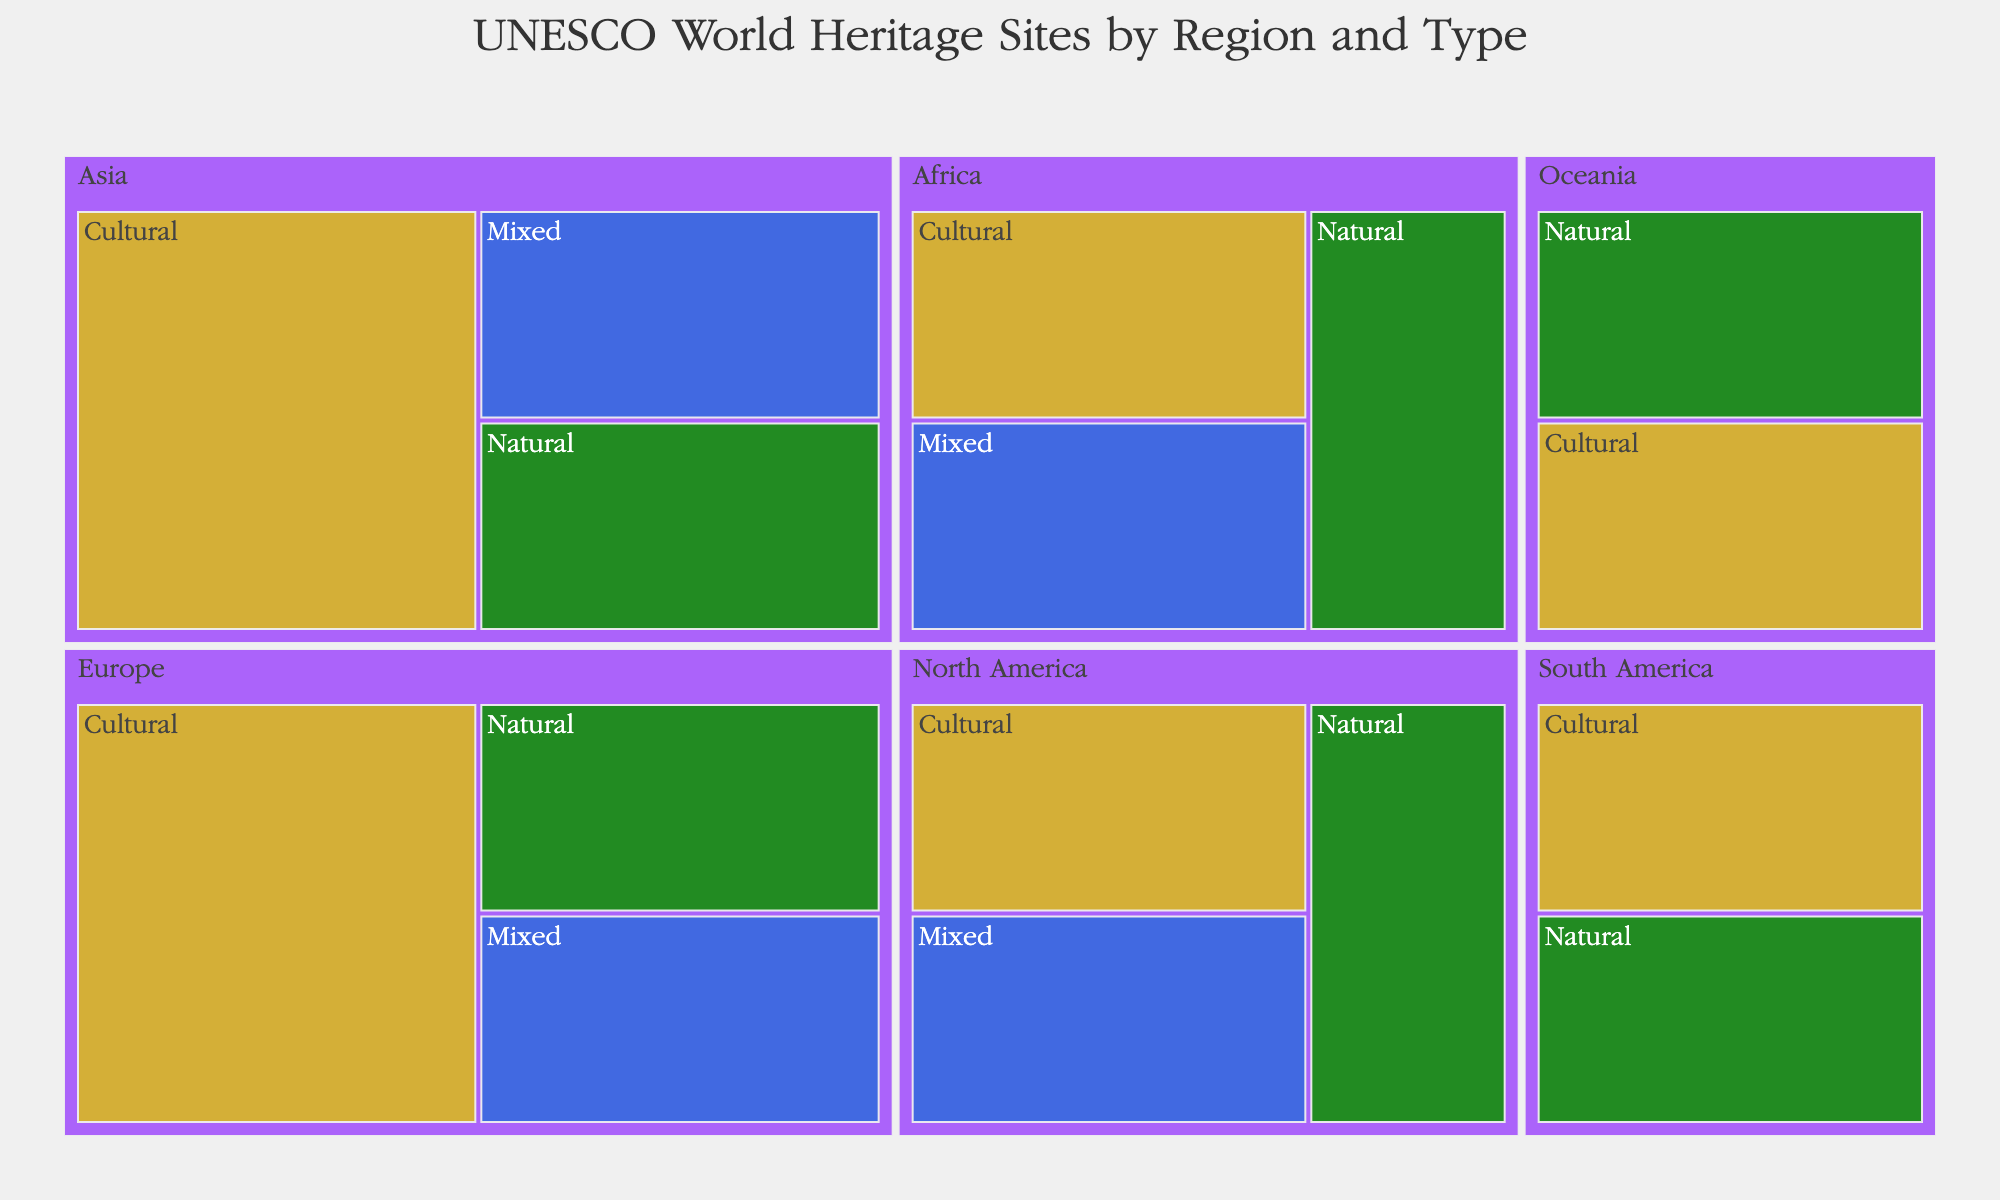What is the title of the treemap? The title is typically displayed at the top of the treemap. It provides a brief description of what the treemap represents.
Answer: UNESCO World Heritage Sites by Region and Type What color represents Natural sites? In the treemap, each type of site is represented by a distinct color. By looking at the color legend or directly at the sections filled with certain colors, we can identify which color corresponds to Natural sites.
Answer: Forest Green How many UNESCO World Heritage Sites are listed in Europe? To find out the total number of sites in Europe, we need to sum the counts for all types in that region. According to the data, Europe has Cultural (1), Natural (1), and Mixed (1) sites. The total number is 1 + 1 + 1.
Answer: 3 Which region has the highest number of Mixed sites? In the treemap, each region has sections representing different types of sites. By identifying the size or count of Mixed sites across different regions, we can determine which region has the highest number.
Answer: It is a tie between Europe, Asia, Africa, and North America How does the count of Cultural sites in Asia compare to the count in South America? By examining the Cultural sections for both Asia and South America and noting the counts in each, we can compare the two. According to the data, Asia has 2 Cultural sites (Great Wall of China and Taj Mahal), and South America has 1 (Historic Centre of Lima). Thus, 2 is greater than 1.
Answer: Asia has more Cultural sites What is the proportion of Natural sites in Africa compared to total sites in Africa? To find this proportion, divide the number of Natural sites in Africa by the total number of sites in Africa. Africa has 1 Natural site (Serengeti National Park) and a total of 3 sites (1 Cultural, 1 Natural, and 1 Mixed). So, 1/3 = 0.33 or 33%.
Answer: 33% Identify all the regions that have Mixed sites. By reviewing the treemap, identify which regions have sections colored for Mixed sites (Royal Blue).
Answer: Europe, Asia, Africa, and North America Which type of site has the least representation overall? To determine which type has the least count, sum the number of sites for Cultural, Natural, and Mixed categories across all regions. Noting the counts in the data: Cultural (8), Natural (6), and Mixed (4) indicates that Mixed sites have the least representation.
Answer: Mixed Are there more Natural sites in Europe or Oceania? In the treemap, compare the count of Natural sites between Europe and Oceania by looking at the counts noted in these regions. Europe's Natural count is 1 (Swiss Alps Jungfrau-Aletsch) and Oceania's is also 1 (Great Barrier Reef). Thus, both are equal.
Answer: Equal How do the total counts of sites in North America and South America compare? To compare, sum the counts for all types of sites in North America and South America. North America has Cultural (1), Natural (1), and Mixed (1) totaling 3. South America has Cultural (1) and Natural (1) totaling 2. Thus, North America has more.
Answer: North America has more 